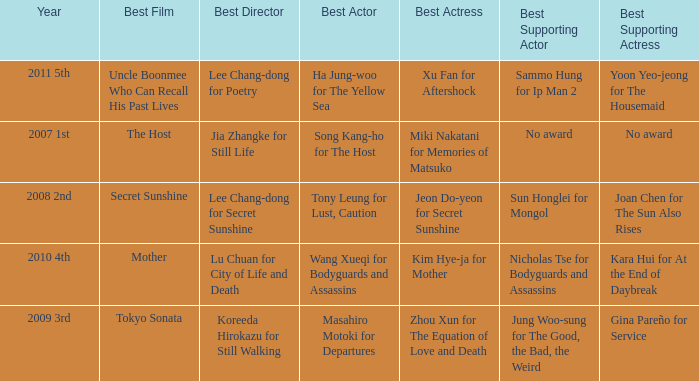Name the best director for mother Lu Chuan for City of Life and Death. 